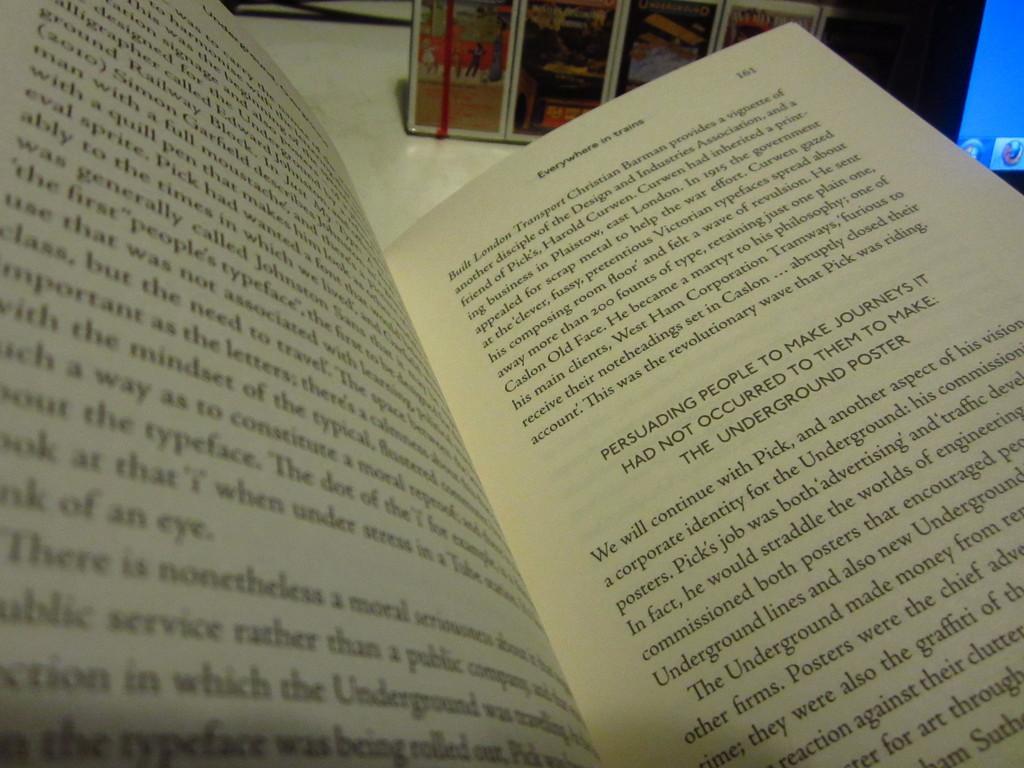<image>
Provide a brief description of the given image. An open book with the header: Everywhere in trains. 